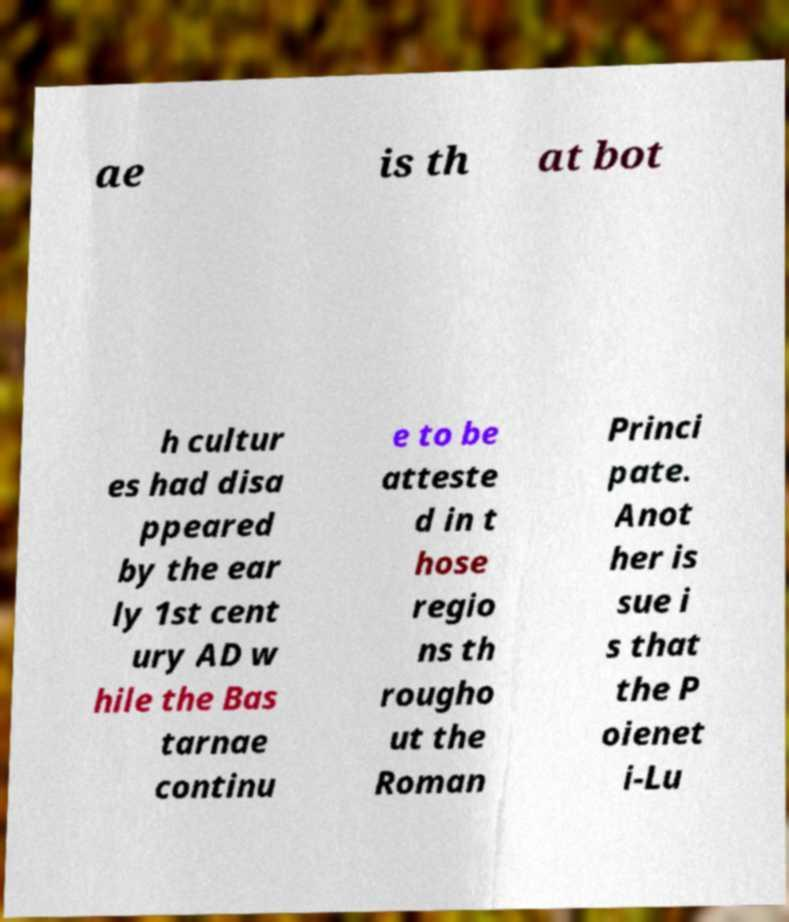I need the written content from this picture converted into text. Can you do that? ae is th at bot h cultur es had disa ppeared by the ear ly 1st cent ury AD w hile the Bas tarnae continu e to be atteste d in t hose regio ns th rougho ut the Roman Princi pate. Anot her is sue i s that the P oienet i-Lu 